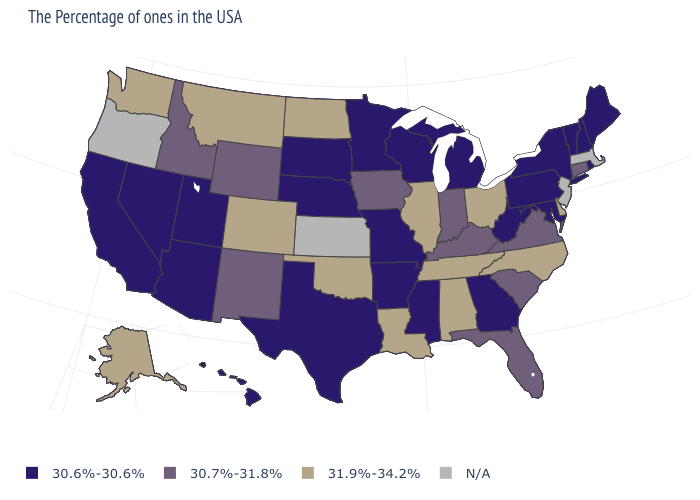Name the states that have a value in the range 31.9%-34.2%?
Short answer required. Delaware, North Carolina, Ohio, Alabama, Tennessee, Illinois, Louisiana, Oklahoma, North Dakota, Colorado, Montana, Washington, Alaska. What is the value of Colorado?
Short answer required. 31.9%-34.2%. Is the legend a continuous bar?
Answer briefly. No. What is the value of Maryland?
Answer briefly. 30.6%-30.6%. Is the legend a continuous bar?
Give a very brief answer. No. Does Indiana have the highest value in the USA?
Answer briefly. No. Which states hav the highest value in the South?
Be succinct. Delaware, North Carolina, Alabama, Tennessee, Louisiana, Oklahoma. Which states have the highest value in the USA?
Keep it brief. Delaware, North Carolina, Ohio, Alabama, Tennessee, Illinois, Louisiana, Oklahoma, North Dakota, Colorado, Montana, Washington, Alaska. What is the highest value in the USA?
Short answer required. 31.9%-34.2%. What is the value of Nebraska?
Concise answer only. 30.6%-30.6%. Does Pennsylvania have the highest value in the USA?
Give a very brief answer. No. Does the first symbol in the legend represent the smallest category?
Concise answer only. Yes. What is the lowest value in the USA?
Concise answer only. 30.6%-30.6%. Name the states that have a value in the range 30.6%-30.6%?
Give a very brief answer. Maine, Rhode Island, New Hampshire, Vermont, New York, Maryland, Pennsylvania, West Virginia, Georgia, Michigan, Wisconsin, Mississippi, Missouri, Arkansas, Minnesota, Nebraska, Texas, South Dakota, Utah, Arizona, Nevada, California, Hawaii. Among the states that border Wisconsin , which have the lowest value?
Be succinct. Michigan, Minnesota. 